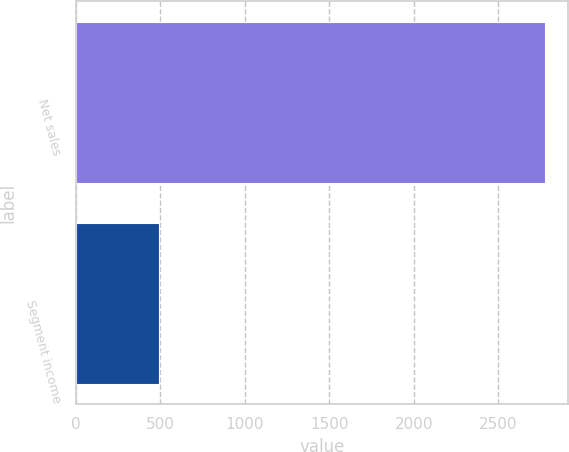<chart> <loc_0><loc_0><loc_500><loc_500><bar_chart><fcel>Net sales<fcel>Segment income<nl><fcel>2777.7<fcel>494<nl></chart> 